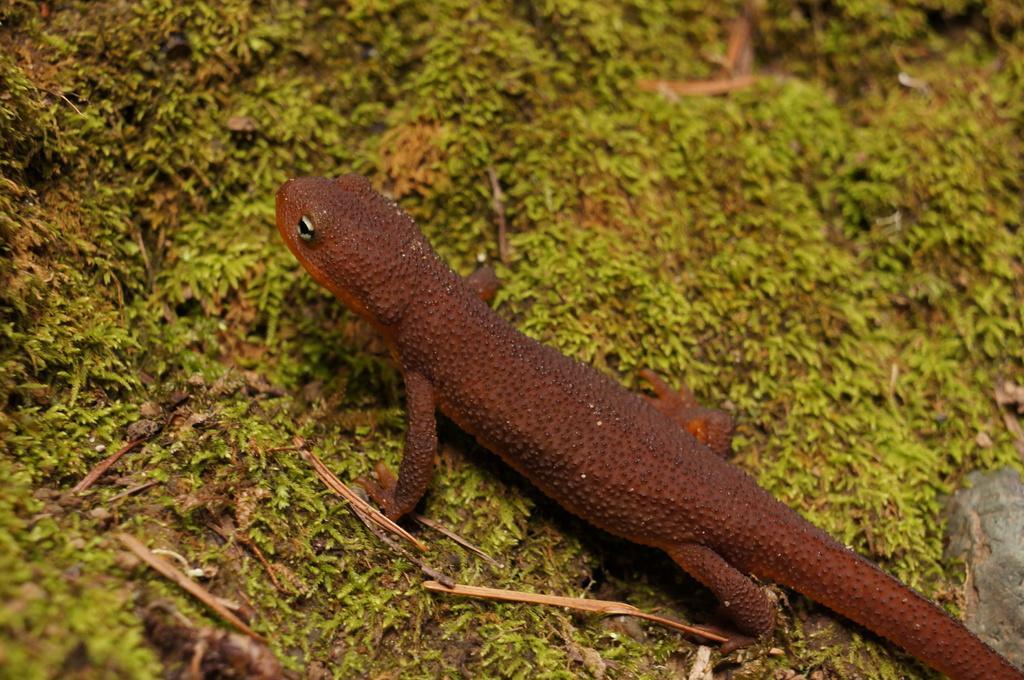Please provide a concise description of this image. In this picture I can see a reptile, there are tiny plants. 